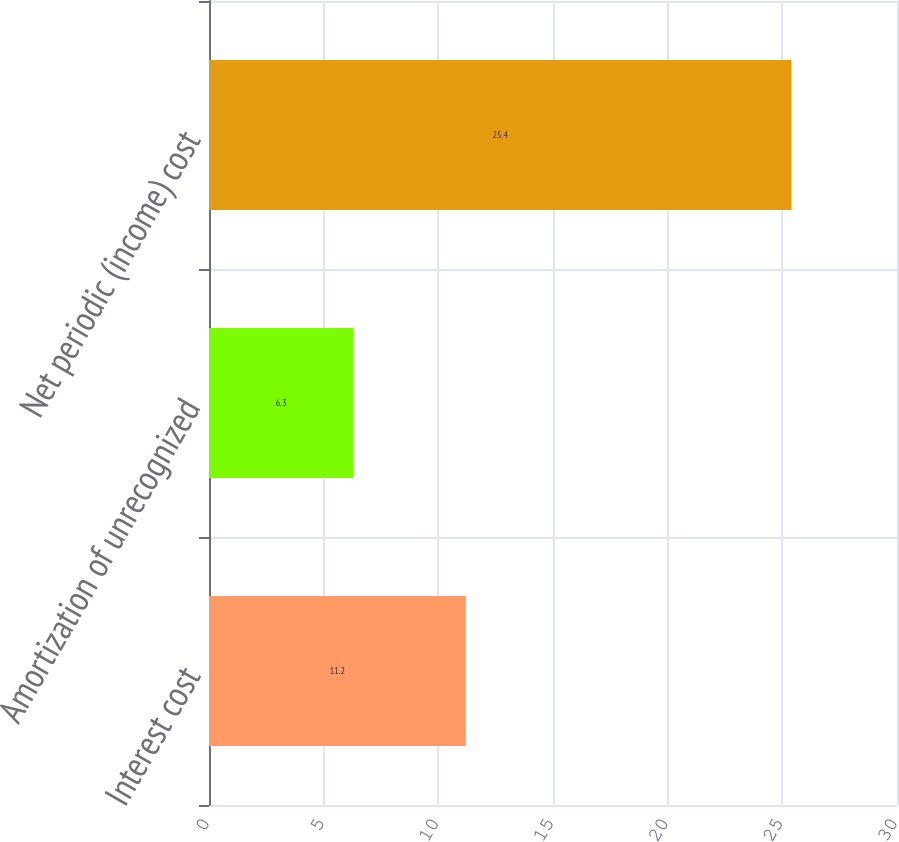Convert chart to OTSL. <chart><loc_0><loc_0><loc_500><loc_500><bar_chart><fcel>Interest cost<fcel>Amortization of unrecognized<fcel>Net periodic (income) cost<nl><fcel>11.2<fcel>6.3<fcel>25.4<nl></chart> 